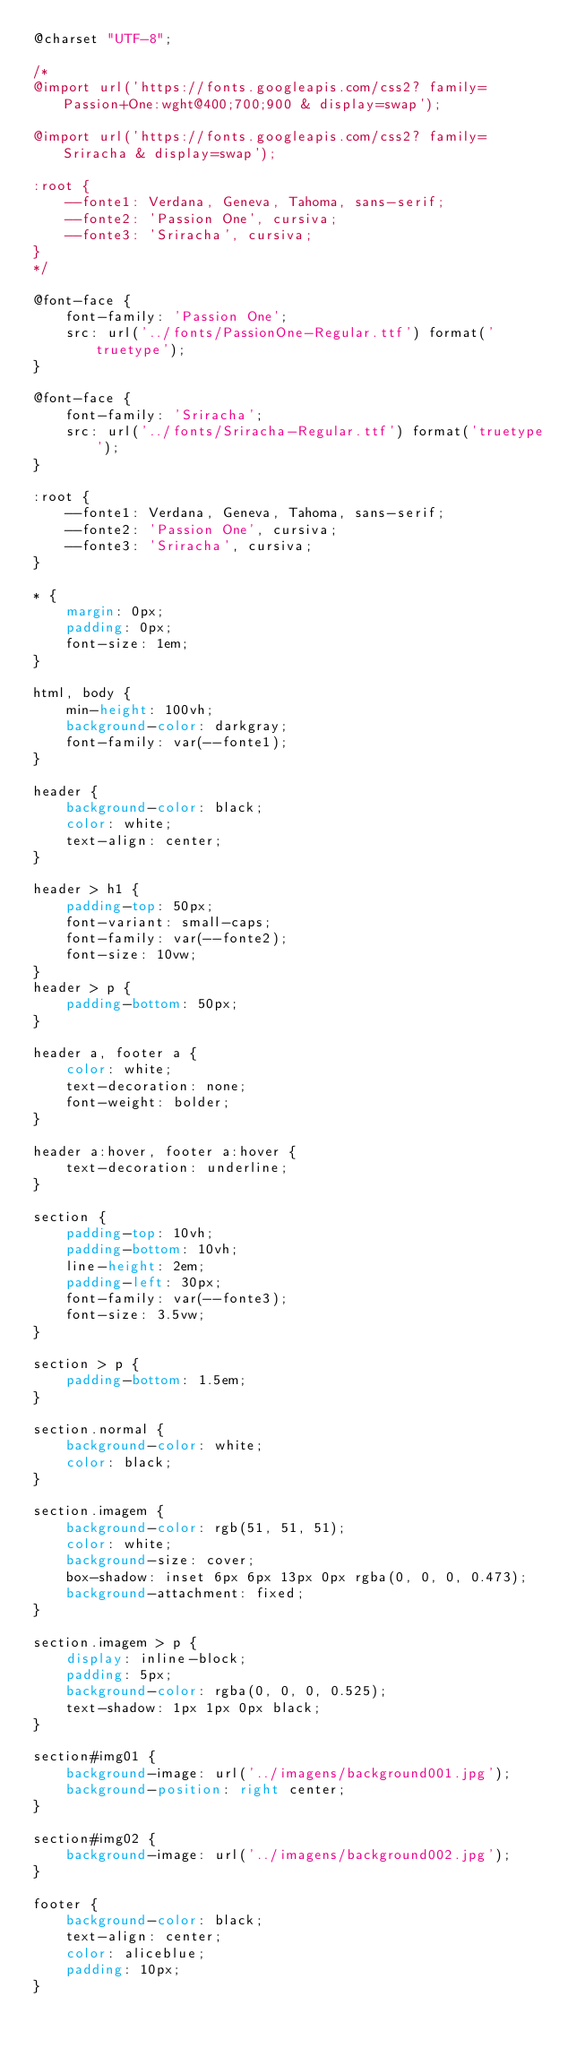Convert code to text. <code><loc_0><loc_0><loc_500><loc_500><_CSS_>@charset "UTF-8";

/*
@import url('https://fonts.googleapis.com/css2? family= Passion+One:wght@400;700;900 & display=swap');

@import url('https://fonts.googleapis.com/css2? family= Sriracha & display=swap');

:root {
    --fonte1: Verdana, Geneva, Tahoma, sans-serif;
    --fonte2: 'Passion One', cursiva;
    --fonte3: 'Sriracha', cursiva;
}
*/

@font-face {
    font-family: 'Passion One';
    src: url('../fonts/PassionOne-Regular.ttf') format('truetype');
}

@font-face {
    font-family: 'Sriracha';
    src: url('../fonts/Sriracha-Regular.ttf') format('truetype');
}

:root {
    --fonte1: Verdana, Geneva, Tahoma, sans-serif;
    --fonte2: 'Passion One', cursiva;
    --fonte3: 'Sriracha', cursiva;
}

* {
    margin: 0px;
    padding: 0px;
    font-size: 1em;
}

html, body {
    min-height: 100vh;
    background-color: darkgray;
    font-family: var(--fonte1);
}

header {
    background-color: black;
    color: white;
    text-align: center;
}

header > h1 {
    padding-top: 50px;
    font-variant: small-caps;
    font-family: var(--fonte2);
    font-size: 10vw;
}
header > p {
    padding-bottom: 50px;
}

header a, footer a {
    color: white;
    text-decoration: none;
    font-weight: bolder;
}

header a:hover, footer a:hover {
    text-decoration: underline;
}

section {
    padding-top: 10vh;
    padding-bottom: 10vh;
    line-height: 2em;
    padding-left: 30px;
    font-family: var(--fonte3);
    font-size: 3.5vw;
}

section > p {
    padding-bottom: 1.5em;
}

section.normal {
    background-color: white;
    color: black;
}

section.imagem {
    background-color: rgb(51, 51, 51);
    color: white;
    background-size: cover;
    box-shadow: inset 6px 6px 13px 0px rgba(0, 0, 0, 0.473);
    background-attachment: fixed;
}

section.imagem > p {
    display: inline-block;
    padding: 5px;
    background-color: rgba(0, 0, 0, 0.525);
    text-shadow: 1px 1px 0px black;
}

section#img01 {
    background-image: url('../imagens/background001.jpg');
    background-position: right center;
}

section#img02 {
    background-image: url('../imagens/background002.jpg');
}

footer {
    background-color: black;
    text-align: center;
    color: aliceblue;
    padding: 10px;
}</code> 